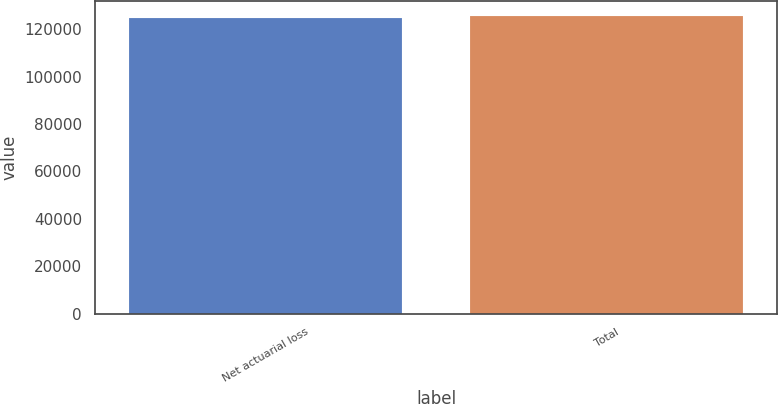Convert chart. <chart><loc_0><loc_0><loc_500><loc_500><bar_chart><fcel>Net actuarial loss<fcel>Total<nl><fcel>124560<fcel>125726<nl></chart> 